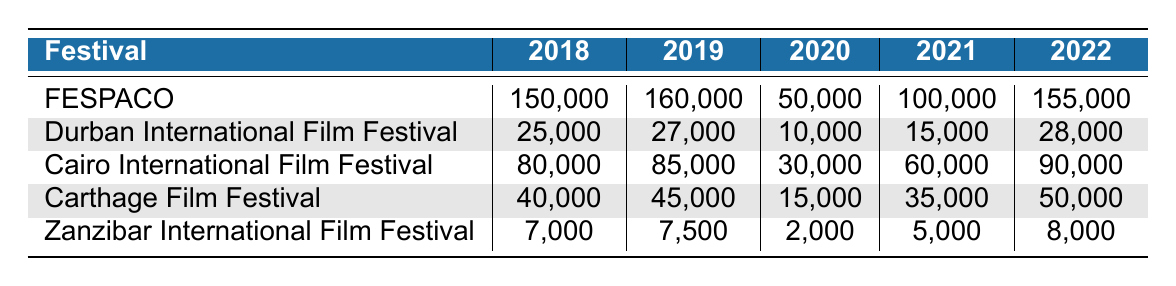What festival had the highest attendance in 2022? In 2022, the attendance figures for the festivals are as follows: FESPACO (155,000), Durban International Film Festival (28,000), Cairo International Film Festival (90,000), Carthage Film Festival (50,000), and Zanzibar International Film Festival (8,000). The highest attendance is 155,000 for FESPACO.
Answer: FESPACO What was the attendance for the Carthage Film Festival in 2020? Looking at the row for the Carthage Film Festival, the attendance in 2020 is provided directly as 15,000.
Answer: 15,000 What is the percentage increase in attendance for FESPACO from 2019 to 2022? FESPACO had an attendance of 160,000 in 2019 and 155,000 in 2022. The change in attendance is 155,000 - 160,000 = -5,000. The percentage change is (-5,000 / 160,000) * 100 = -3.125%.
Answer: -3.125% What was the average attendance for the Zanzibar International Film Festival across all years? The attendance figures for Zanzibar from 2018 to 2022 are: 7,000, 7,500, 2,000, 5,000, and 8,000. To find the average, sum these values (7,000 + 7,500 + 2,000 + 5,000 + 8,000 = 29,500) and divide by 5 (29,500 / 5 = 5,900).
Answer: 5,900 Did the attendance for the Durban International Film Festival increase every year from 2018 to 2022? The attendance numbers for Durban are: 25,000 (2018), 27,000 (2019), 10,000 (2020), 15,000 (2021), and 28,000 (2022). From 2019 to 2020, the attendance decreased significantly from 27,000 to 10,000, indicating it did not increase every year.
Answer: No What is the total attendance for the Cairo International Film Festival over all the years? The total attendance for Cairo from 2018 to 2022 is: 80,000 + 85,000 + 30,000 + 60,000 + 90,000 = 345,000.
Answer: 345,000 Which festival had the lowest attendance in 2021? The attendance figures for 2021 are: FESPACO (100,000), Durban International Film Festival (15,000), Cairo International Film Festival (60,000), Carthage Film Festival (35,000), and Zanzibar International Film Festival (5,000). The lowest attendance is 5,000 for Zanzibar International Film Festival.
Answer: Zanzibar International Film Festival What was the overall trend of attendance for FESPACO from 2018 to 2022? The attendance figures for FESPACO over the years are: 150,000 (2018), 160,000 (2019), 50,000 (2020), 100,000 (2021), and 155,000 (2022). The trend shows a peak in 2019, a significant drop in 2020, an increase in 2021, and a slight decrease in 2022. Therefore, the overall trend fluctuated.
Answer: Fluctuated Which festival had the highest attendance in 2020 and how many attendees? The attendance for the year 2020 is as follows: FESPACO (50,000), Durban International Film Festival (10,000), Cairo International Film Festival (30,000), Carthage Film Festival (15,000), and Zanzibar International Film Festival (2,000). The festival with the highest attendance in 2020 is FESPACO with 50,000.
Answer: FESPACO, 50,000 What was the trend in attendance at the Durban International Film Festival from 2018 to 2022? For Durban, the attendance figures are: 25,000 (2018), 27,000 (2019), 10,000 (2020), 15,000 (2021), and 28,000 (2022). The trend indicates an increase from 2018 to 2019, a sharp decline in 2020, a slight increase in 2021, followed by a rise in 2022. Overall, it was inconsistent.
Answer: Inconsistent 